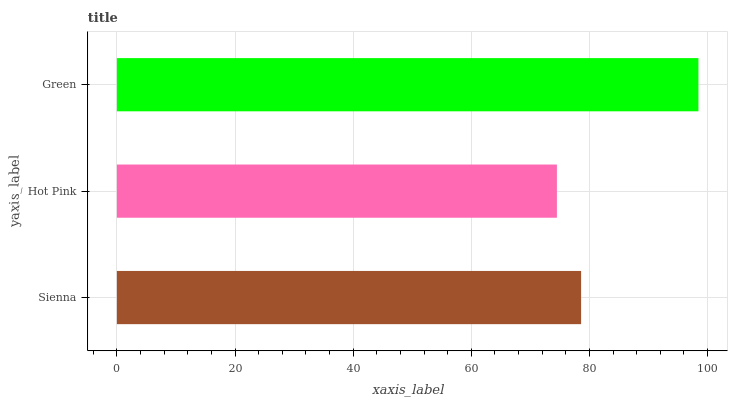Is Hot Pink the minimum?
Answer yes or no. Yes. Is Green the maximum?
Answer yes or no. Yes. Is Green the minimum?
Answer yes or no. No. Is Hot Pink the maximum?
Answer yes or no. No. Is Green greater than Hot Pink?
Answer yes or no. Yes. Is Hot Pink less than Green?
Answer yes or no. Yes. Is Hot Pink greater than Green?
Answer yes or no. No. Is Green less than Hot Pink?
Answer yes or no. No. Is Sienna the high median?
Answer yes or no. Yes. Is Sienna the low median?
Answer yes or no. Yes. Is Hot Pink the high median?
Answer yes or no. No. Is Green the low median?
Answer yes or no. No. 